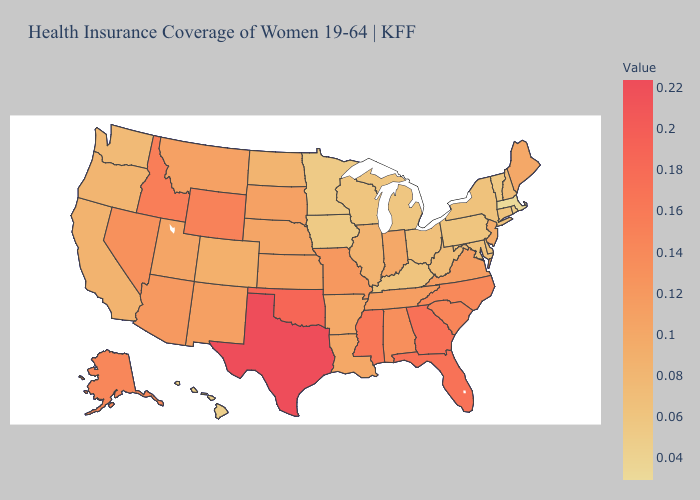Does Michigan have a lower value than Massachusetts?
Keep it brief. No. Does Washington have the highest value in the USA?
Quick response, please. No. Is the legend a continuous bar?
Quick response, please. Yes. Is the legend a continuous bar?
Quick response, please. Yes. Which states have the highest value in the USA?
Quick response, please. Texas. 